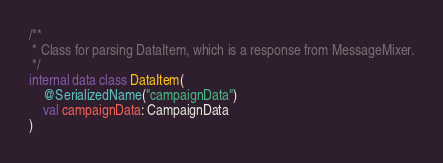Convert code to text. <code><loc_0><loc_0><loc_500><loc_500><_Kotlin_>
/**
 * Class for parsing DataItem, which is a response from MessageMixer.
 */
internal data class DataItem(
    @SerializedName("campaignData")
    val campaignData: CampaignData
)
</code> 